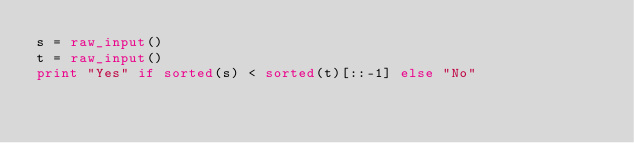<code> <loc_0><loc_0><loc_500><loc_500><_Python_>s = raw_input()
t = raw_input()
print "Yes" if sorted(s) < sorted(t)[::-1] else "No"</code> 